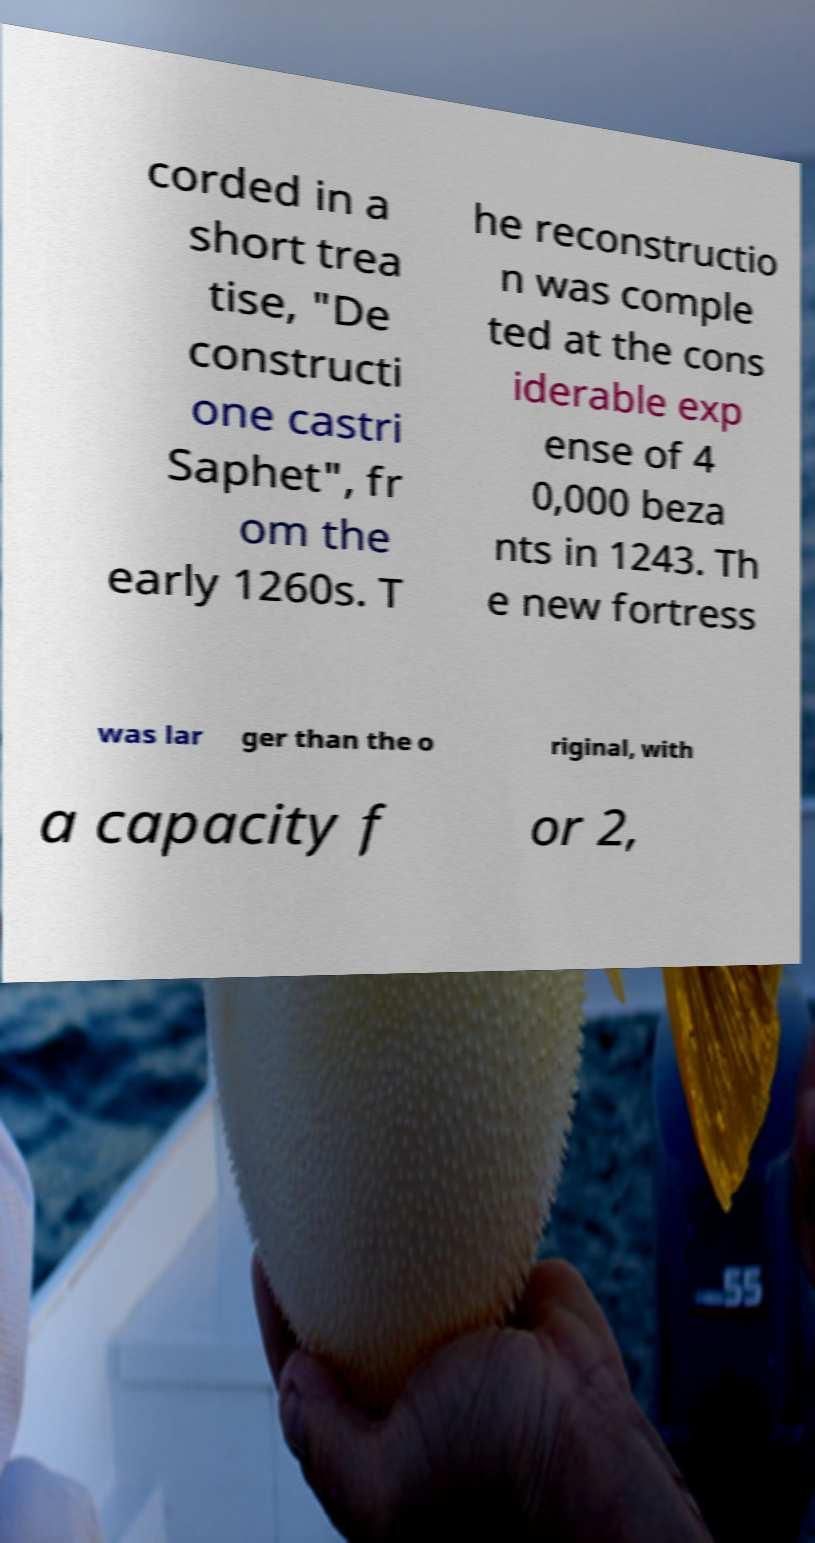Please identify and transcribe the text found in this image. corded in a short trea tise, "De constructi one castri Saphet", fr om the early 1260s. T he reconstructio n was comple ted at the cons iderable exp ense of 4 0,000 beza nts in 1243. Th e new fortress was lar ger than the o riginal, with a capacity f or 2, 